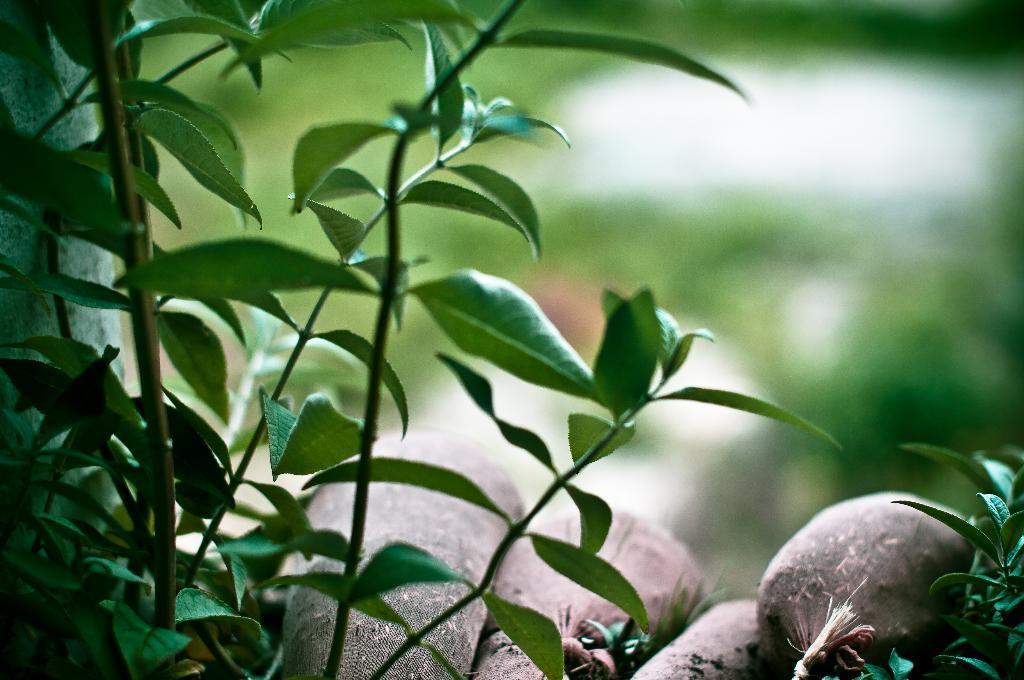Please provide a concise description of this image. In this image we can see leaves, stems and one brown color thing. The background is blurry. 